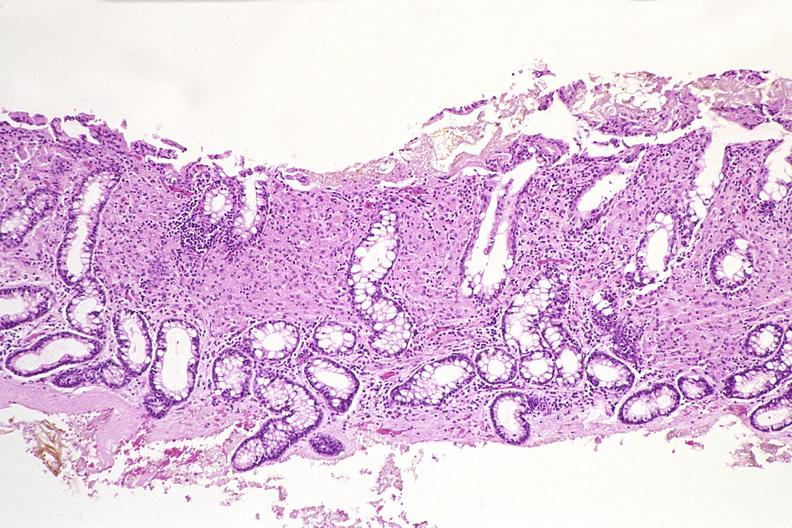s gastrointestinal present?
Answer the question using a single word or phrase. Yes 